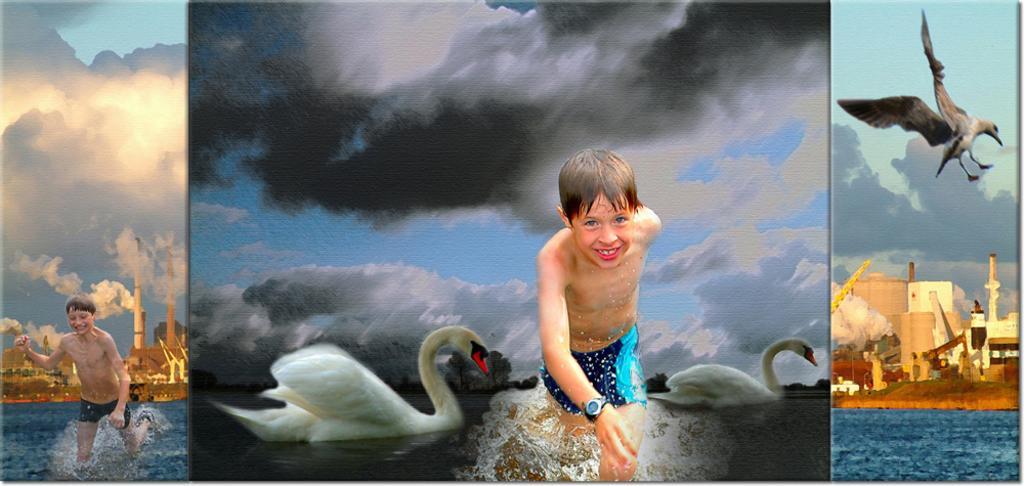In one or two sentences, can you explain what this image depicts? This is an edited image with the college of images. On the right there is a bird flying in the sky and we can see the buildings and a water body. In the center there is a kid seems to be running and there are two swans in the water body. On the left there is a person seems to be running and we can see the water body and the buildings. In the background we can see the sky which is full of clouds. 